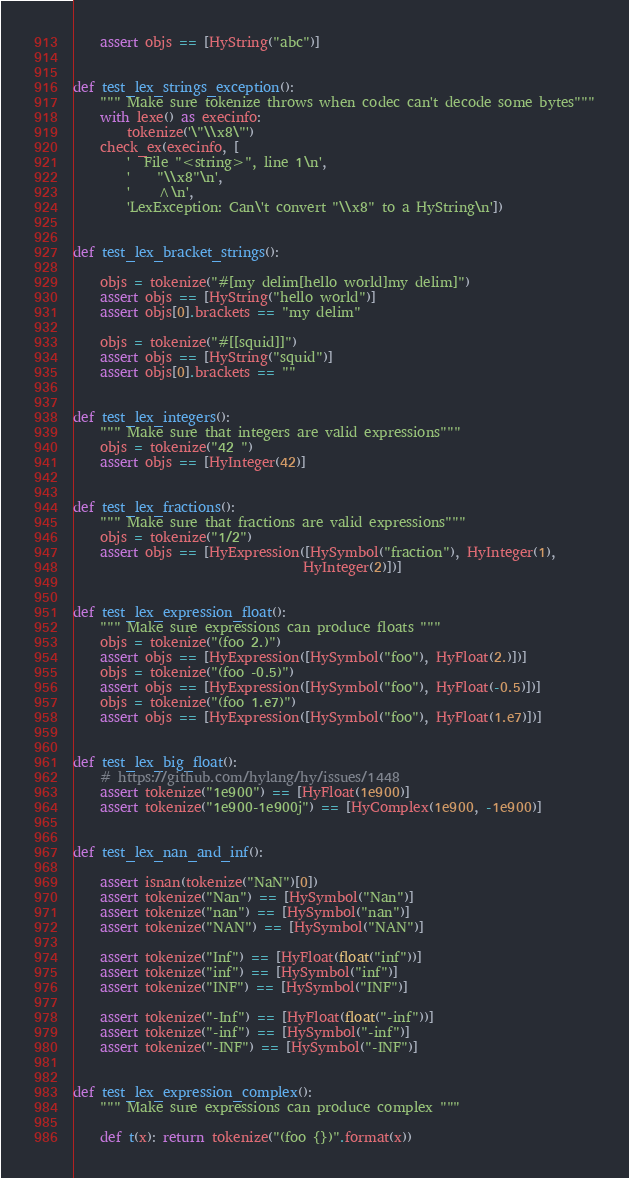<code> <loc_0><loc_0><loc_500><loc_500><_Python_>    assert objs == [HyString("abc")]


def test_lex_strings_exception():
    """ Make sure tokenize throws when codec can't decode some bytes"""
    with lexe() as execinfo:
        tokenize('\"\\x8\"')
    check_ex(execinfo, [
        '  File "<string>", line 1\n',
        '    "\\x8"\n',
        '    ^\n',
        'LexException: Can\'t convert "\\x8" to a HyString\n'])


def test_lex_bracket_strings():

    objs = tokenize("#[my delim[hello world]my delim]")
    assert objs == [HyString("hello world")]
    assert objs[0].brackets == "my delim"

    objs = tokenize("#[[squid]]")
    assert objs == [HyString("squid")]
    assert objs[0].brackets == ""


def test_lex_integers():
    """ Make sure that integers are valid expressions"""
    objs = tokenize("42 ")
    assert objs == [HyInteger(42)]


def test_lex_fractions():
    """ Make sure that fractions are valid expressions"""
    objs = tokenize("1/2")
    assert objs == [HyExpression([HySymbol("fraction"), HyInteger(1),
                                  HyInteger(2)])]


def test_lex_expression_float():
    """ Make sure expressions can produce floats """
    objs = tokenize("(foo 2.)")
    assert objs == [HyExpression([HySymbol("foo"), HyFloat(2.)])]
    objs = tokenize("(foo -0.5)")
    assert objs == [HyExpression([HySymbol("foo"), HyFloat(-0.5)])]
    objs = tokenize("(foo 1.e7)")
    assert objs == [HyExpression([HySymbol("foo"), HyFloat(1.e7)])]


def test_lex_big_float():
    # https://github.com/hylang/hy/issues/1448
    assert tokenize("1e900") == [HyFloat(1e900)]
    assert tokenize("1e900-1e900j") == [HyComplex(1e900, -1e900)]


def test_lex_nan_and_inf():

    assert isnan(tokenize("NaN")[0])
    assert tokenize("Nan") == [HySymbol("Nan")]
    assert tokenize("nan") == [HySymbol("nan")]
    assert tokenize("NAN") == [HySymbol("NAN")]

    assert tokenize("Inf") == [HyFloat(float("inf"))]
    assert tokenize("inf") == [HySymbol("inf")]
    assert tokenize("INF") == [HySymbol("INF")]

    assert tokenize("-Inf") == [HyFloat(float("-inf"))]
    assert tokenize("-inf") == [HySymbol("-inf")]
    assert tokenize("-INF") == [HySymbol("-INF")]


def test_lex_expression_complex():
    """ Make sure expressions can produce complex """

    def t(x): return tokenize("(foo {})".format(x))
</code> 